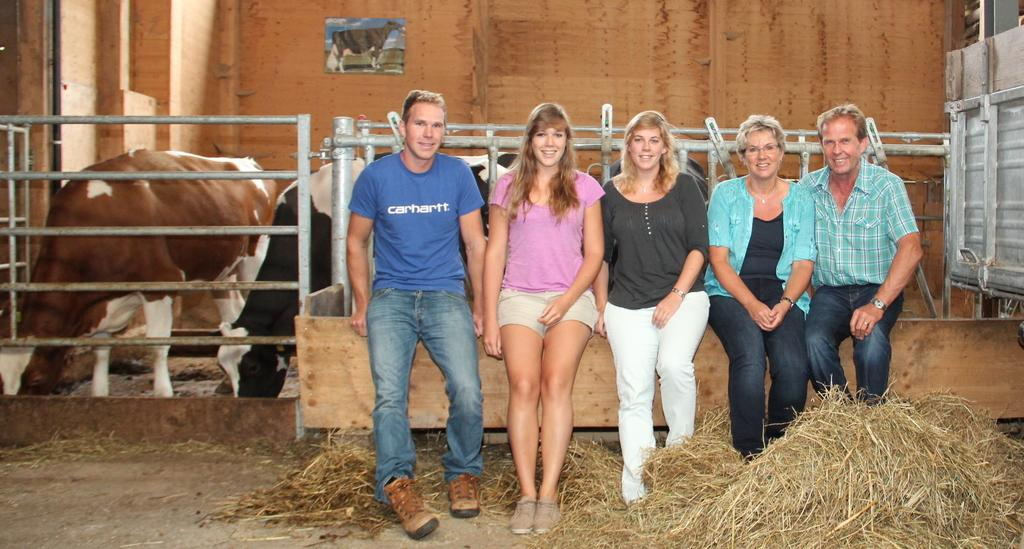How many people are present in the image? There are five people in the image, three women and two men. What are the people doing in the image? The people are sitting. What are the people wearing in the image? The people are wearing clothes, and some of them are wearing shoes and wrist watches. What can be seen in the background of the image? There is dry grass, a fence, and cows in the image. What type of blade is being used to cut the cows in the image? There is no blade or cutting of cows depicted in the image; the cows are simply present in the background. 